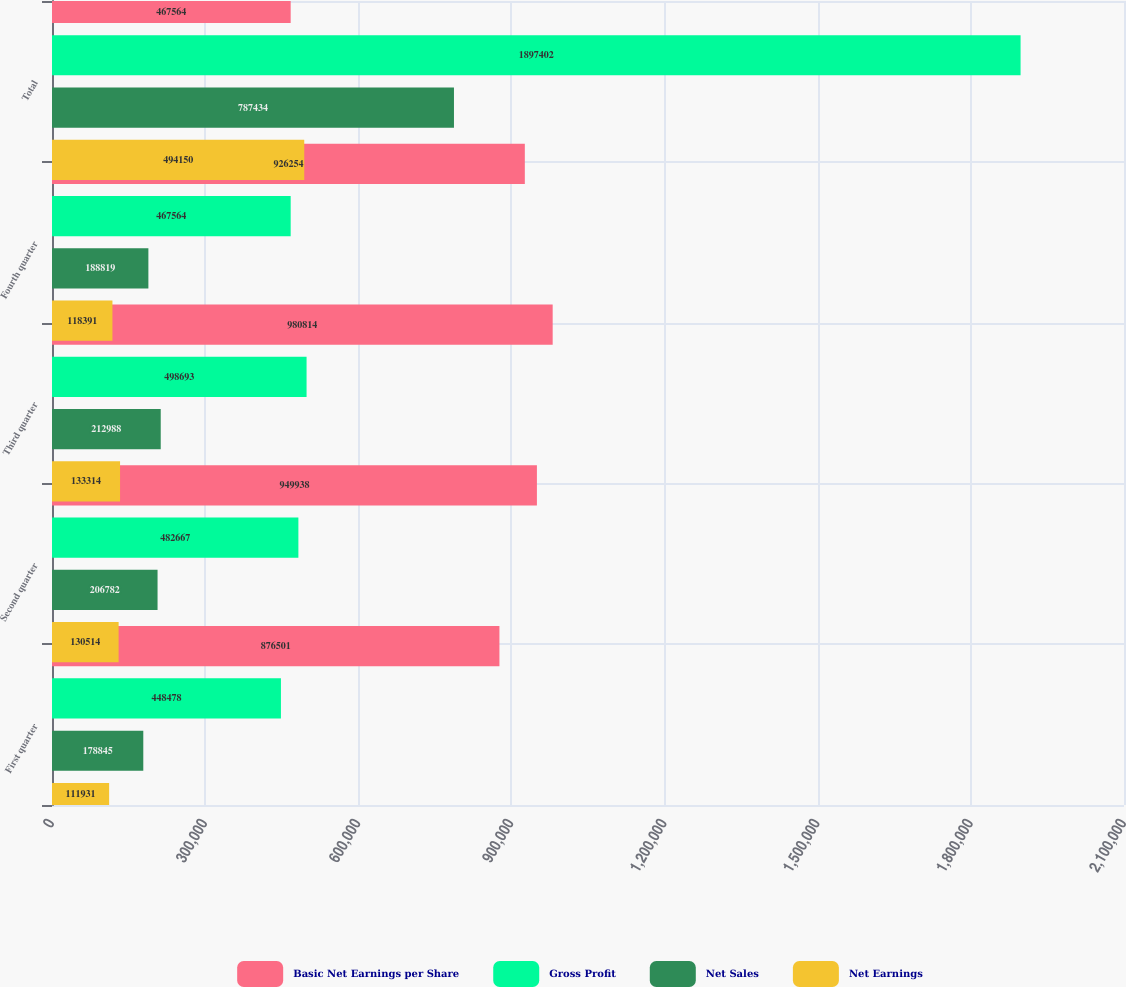Convert chart. <chart><loc_0><loc_0><loc_500><loc_500><stacked_bar_chart><ecel><fcel>First quarter<fcel>Second quarter<fcel>Third quarter<fcel>Fourth quarter<fcel>Total<nl><fcel>Basic Net Earnings per Share<fcel>876501<fcel>949938<fcel>980814<fcel>926254<fcel>467564<nl><fcel>Gross Profit<fcel>448478<fcel>482667<fcel>498693<fcel>467564<fcel>1.8974e+06<nl><fcel>Net Sales<fcel>178845<fcel>206782<fcel>212988<fcel>188819<fcel>787434<nl><fcel>Net Earnings<fcel>111931<fcel>130514<fcel>133314<fcel>118391<fcel>494150<nl></chart> 